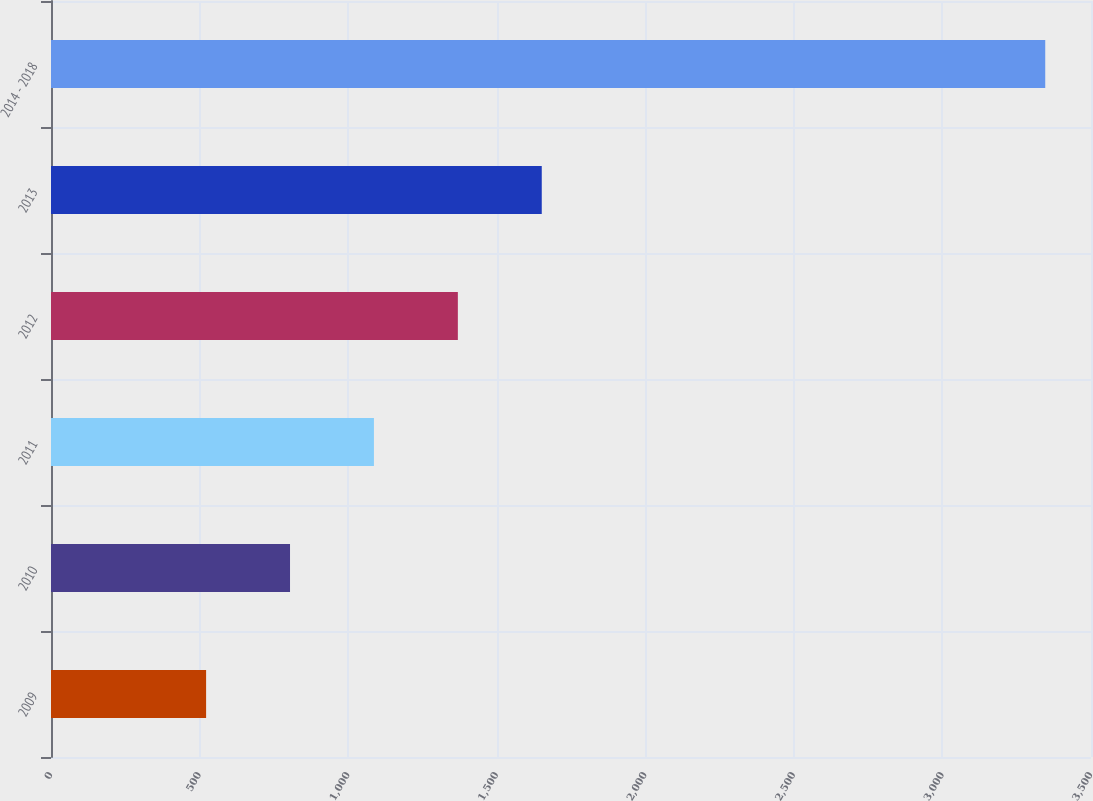<chart> <loc_0><loc_0><loc_500><loc_500><bar_chart><fcel>2009<fcel>2010<fcel>2011<fcel>2012<fcel>2013<fcel>2014 - 2018<nl><fcel>522<fcel>804.4<fcel>1086.8<fcel>1369.2<fcel>1651.6<fcel>3346<nl></chart> 